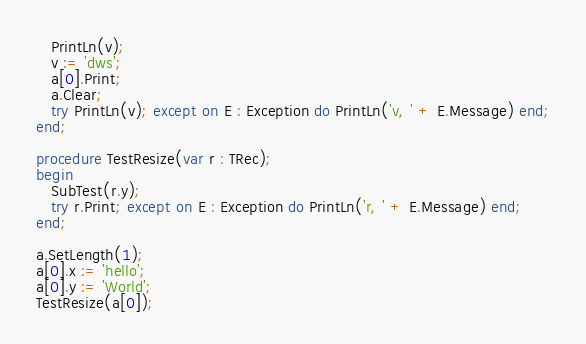Convert code to text. <code><loc_0><loc_0><loc_500><loc_500><_Pascal_>   PrintLn(v);
   v := 'dws';
   a[0].Print;
   a.Clear;
   try PrintLn(v); except on E : Exception do PrintLn('v, ' + E.Message) end;
end;

procedure TestResize(var r : TRec);
begin
   SubTest(r.y);
   try r.Print; except on E : Exception do PrintLn('r, ' + E.Message) end;
end;

a.SetLength(1);
a[0].x := 'hello';
a[0].y := 'World';
TestResize(a[0]);

</code> 